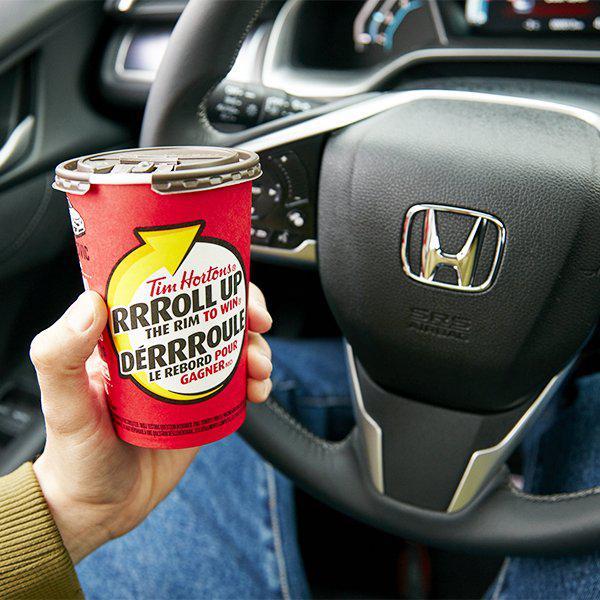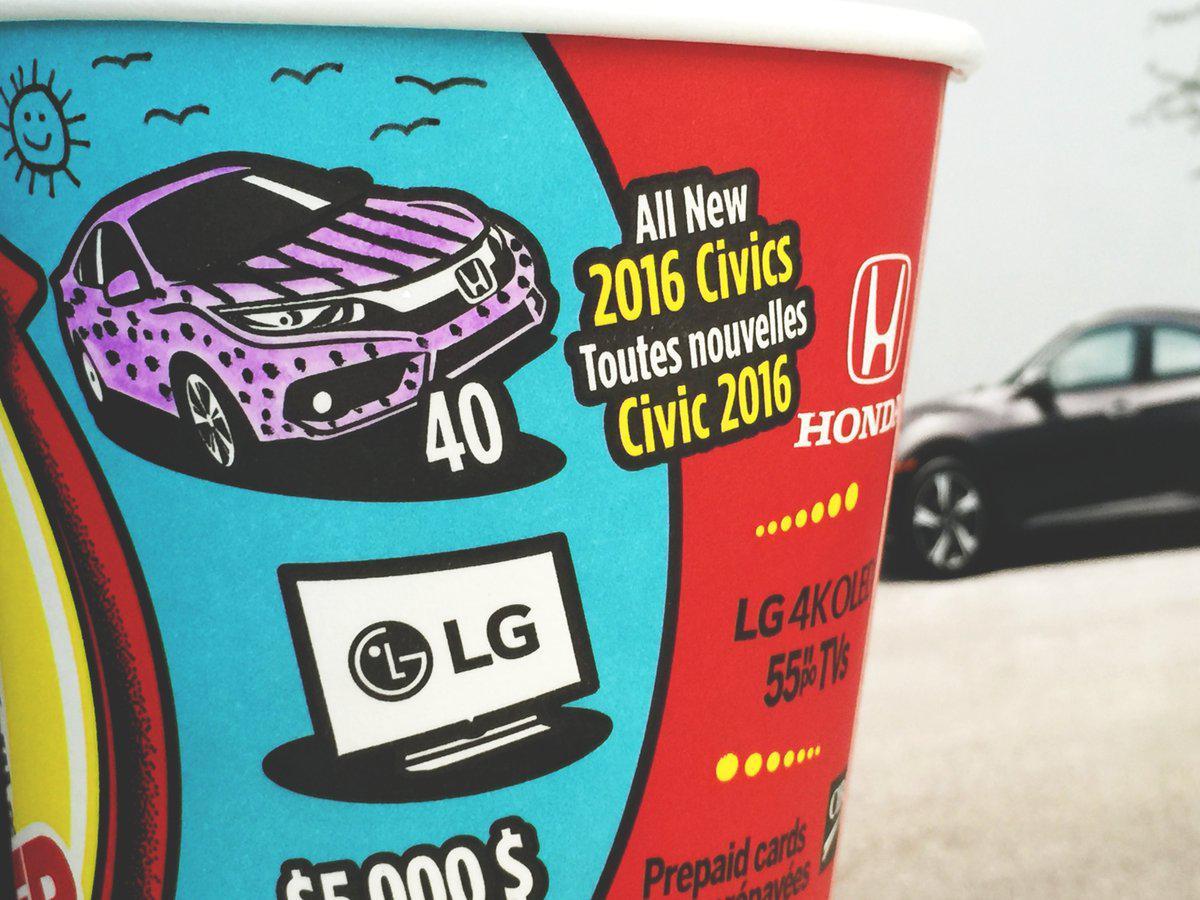The first image is the image on the left, the second image is the image on the right. For the images displayed, is the sentence "A person is holding a cup in one of the images." factually correct? Answer yes or no. Yes. The first image is the image on the left, the second image is the image on the right. Assess this claim about the two images: "There are two red cups with one being held by a hand.". Correct or not? Answer yes or no. Yes. 